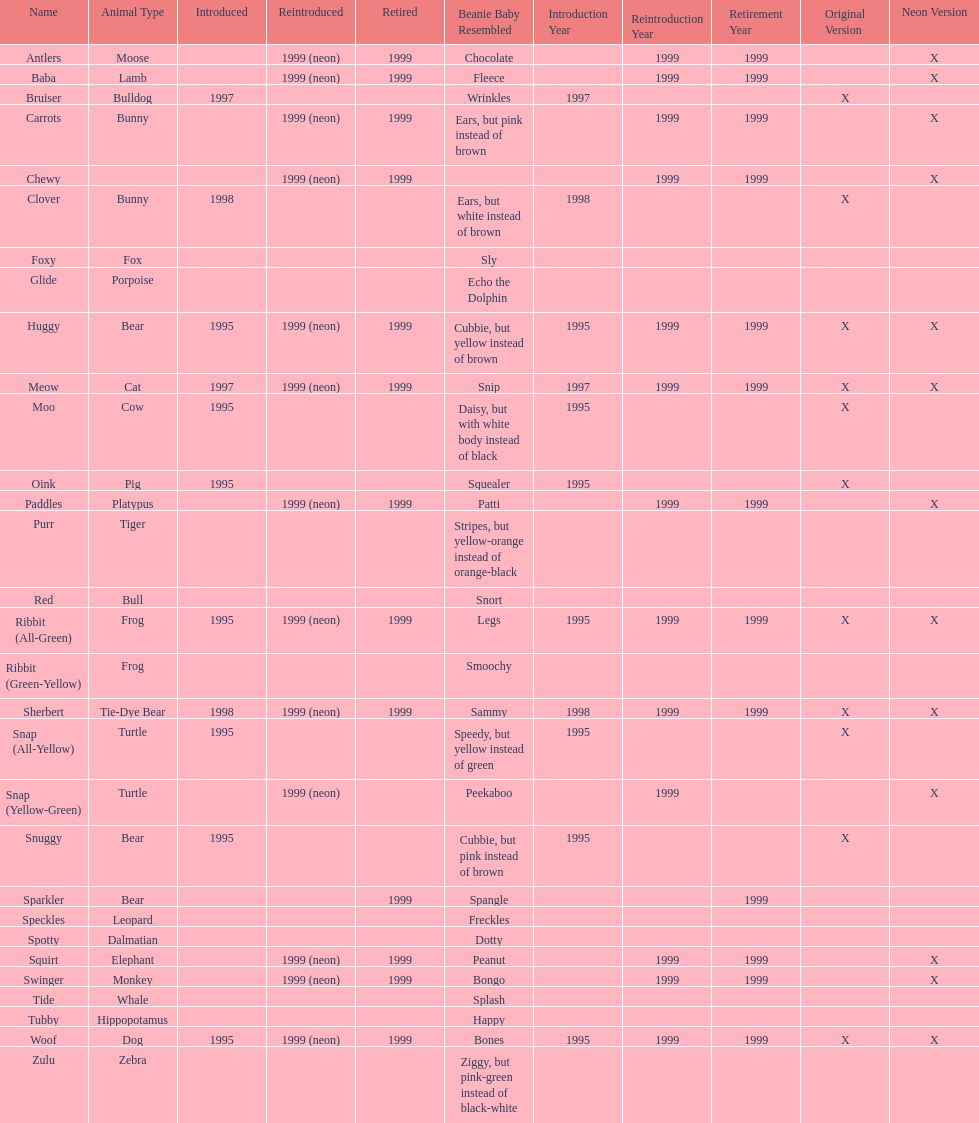What is the number of frog pillow pals? 2. 